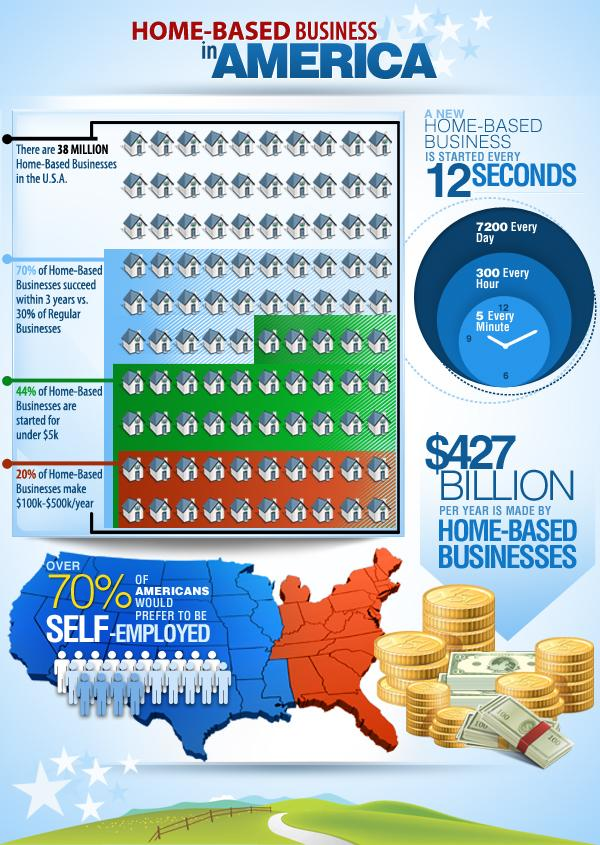Specify some key components in this picture. According to the given statistic, a significant majority of home-based businesses, approximately 56%, are not started with an investment of under $5,000. Home-based businesses are more likely to succeed in three years than regular businesses. The majority of Americans prefer to be self-employed rather than to hold other types of jobs. According to a recent study, approximately 80% of home-based businesses are generating either less than $100,000 or more than $500,000 in annual revenue. Every two minutes, an average of 10 home-based businesses have been started in the United States alone. 